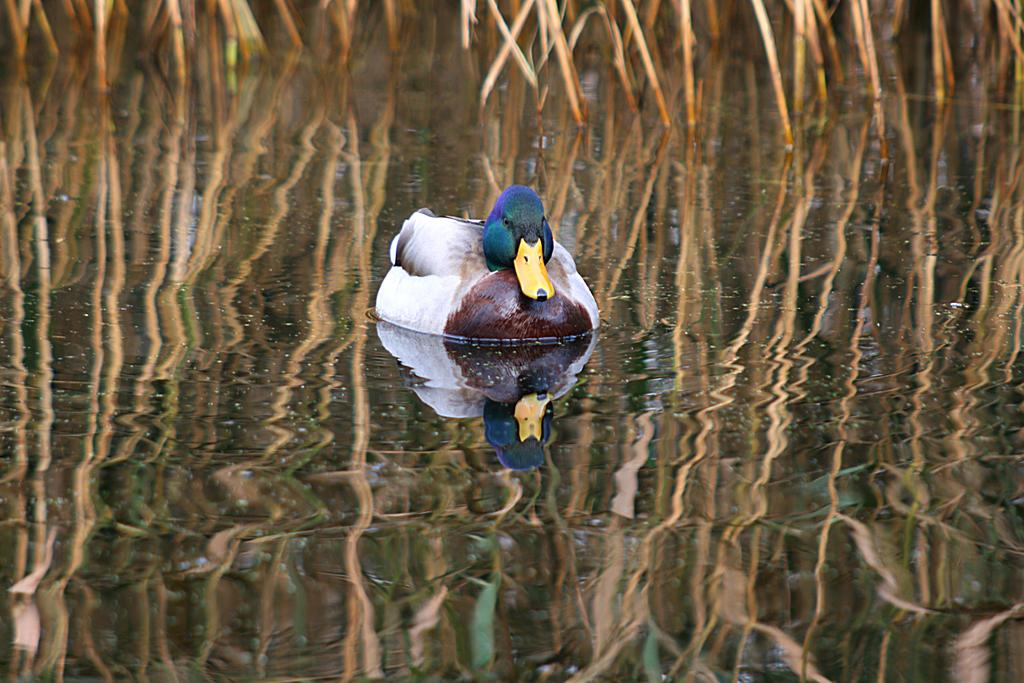What animal is present in the image? There is a duck in the image. Where is the duck located? The duck is on the water. What else can be seen in the image besides the duck? The reflection of the duck and plants is visible at the bottom of the image. How many cars can be seen driving through the water in the image? There are no cars present in the image; it features a duck on the water. What type of thrill can be experienced by the duck in the image? The image does not convey any sense of thrill or excitement for the duck; it is simply depicted on the water. 